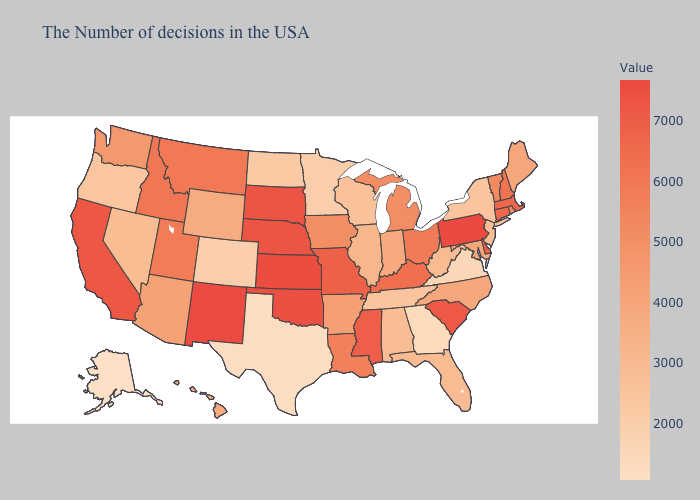Does Missouri have a higher value than Louisiana?
Give a very brief answer. Yes. Which states hav the highest value in the MidWest?
Give a very brief answer. Kansas. 